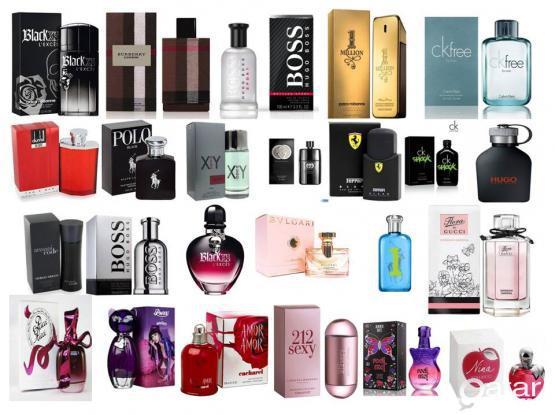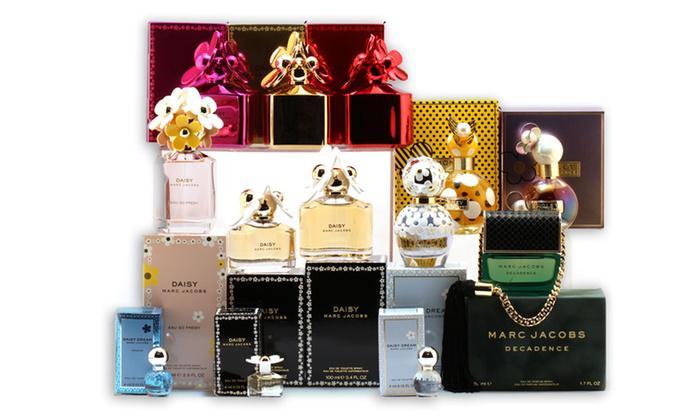The first image is the image on the left, the second image is the image on the right. Evaluate the accuracy of this statement regarding the images: "One image shows exactly one fragrance bottle next to its box but not overlapping it.". Is it true? Answer yes or no. No. The first image is the image on the left, the second image is the image on the right. For the images displayed, is the sentence "There is a single glass bottle of perfume next to it's box with a clear cap" factually correct? Answer yes or no. No. 